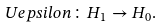Convert formula to latex. <formula><loc_0><loc_0><loc_500><loc_500>\ U e p s i l o n \colon H _ { 1 } \to H _ { 0 } .</formula> 